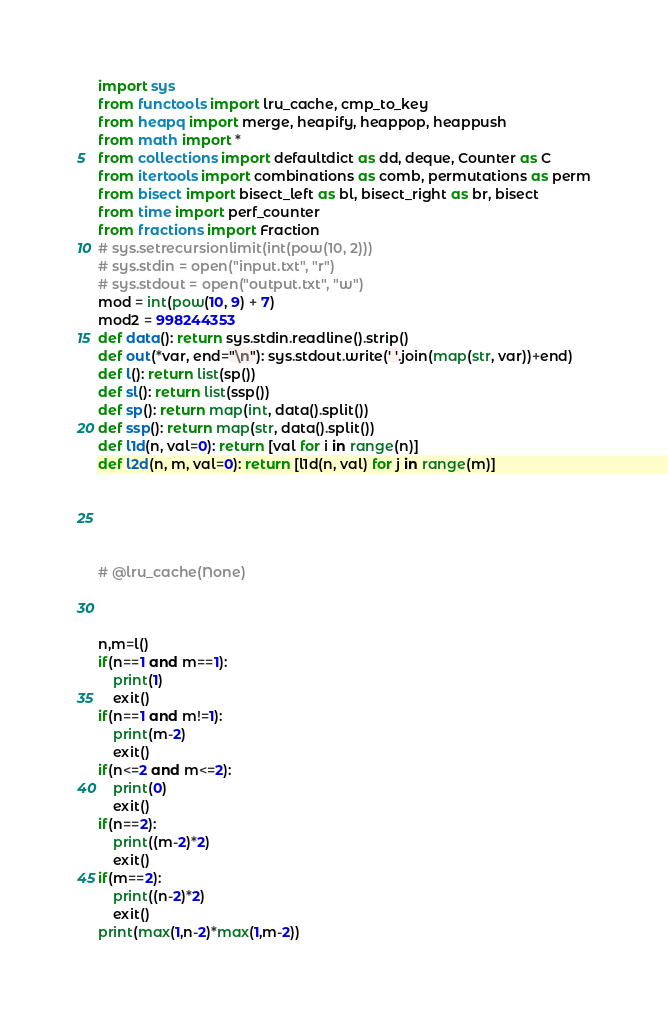<code> <loc_0><loc_0><loc_500><loc_500><_Python_>import sys
from functools import lru_cache, cmp_to_key
from heapq import merge, heapify, heappop, heappush
from math import *
from collections import defaultdict as dd, deque, Counter as C
from itertools import combinations as comb, permutations as perm
from bisect import bisect_left as bl, bisect_right as br, bisect
from time import perf_counter
from fractions import Fraction
# sys.setrecursionlimit(int(pow(10, 2)))
# sys.stdin = open("input.txt", "r")
# sys.stdout = open("output.txt", "w")
mod = int(pow(10, 9) + 7)
mod2 = 998244353
def data(): return sys.stdin.readline().strip()
def out(*var, end="\n"): sys.stdout.write(' '.join(map(str, var))+end)
def l(): return list(sp())
def sl(): return list(ssp())
def sp(): return map(int, data().split())
def ssp(): return map(str, data().split())
def l1d(n, val=0): return [val for i in range(n)]
def l2d(n, m, val=0): return [l1d(n, val) for j in range(m)]





# @lru_cache(None)



n,m=l()
if(n==1 and m==1):
    print(1)
    exit()
if(n==1 and m!=1):
    print(m-2)
    exit()
if(n<=2 and m<=2):
    print(0)
    exit()
if(n==2):
    print((m-2)*2)
    exit()
if(m==2):
    print((n-2)*2)
    exit()
print(max(1,n-2)*max(1,m-2))

</code> 